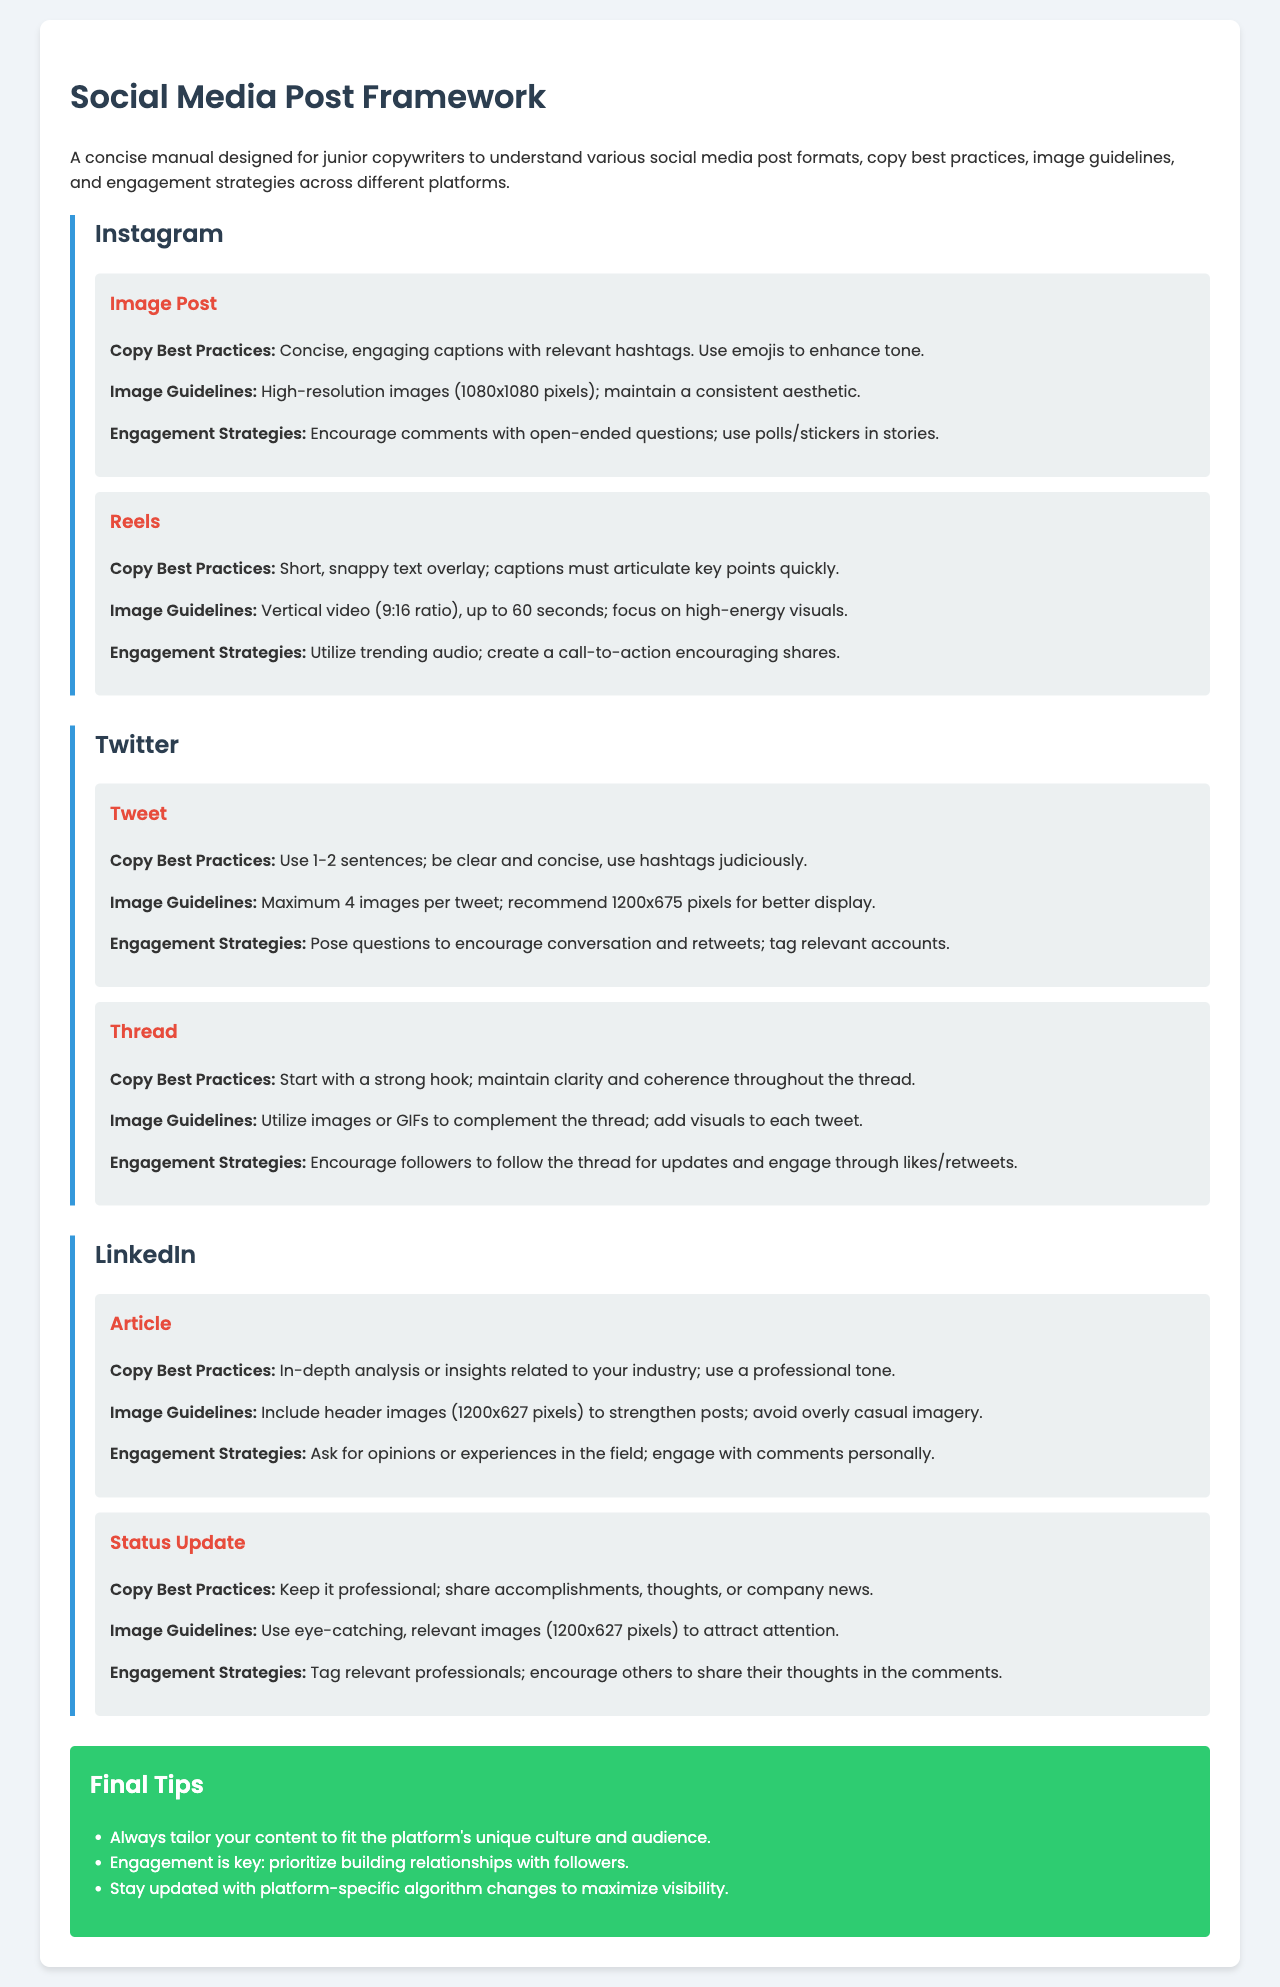What is the recommended image size for Instagram image posts? The image guidelines specify high-resolution images of 1080x1080 pixels for Instagram image posts.
Answer: 1080x1080 pixels What is the maximum video length for Instagram Reels? The post format for Reels indicates that the maximum length is 60 seconds.
Answer: 60 seconds What is the preferred tone for LinkedIn articles? The copy best practices suggest using a professional tone for LinkedIn articles.
Answer: Professional tone What engagement strategy is recommended for Twitter threads? The engagement strategy advises encouraging followers to follow the thread for updates.
Answer: Follow the thread What should you do to enhance engagement on Instagram? The engagement strategies recommend using polls/stickers in stories to encourage comments.
Answer: Use polls/stickers What is the image size for LinkedIn status updates? The image guidelines state that eye-catching, relevant images should be 1200x627 pixels for LinkedIn status updates.
Answer: 1200x627 pixels What is one of the final tips provided in the document? The final tips section indicates that engagement is key, emphasizing the importance of building relationships.
Answer: Engage with followers How many images are allowed per Tweet on Twitter? The image guidelines state that a maximum of 4 images are allowed per Tweet.
Answer: 4 images What type of post is recommended for professional achievements on LinkedIn? The copy best practices suggest that status updates are appropriate for sharing accomplishments.
Answer: Status update 